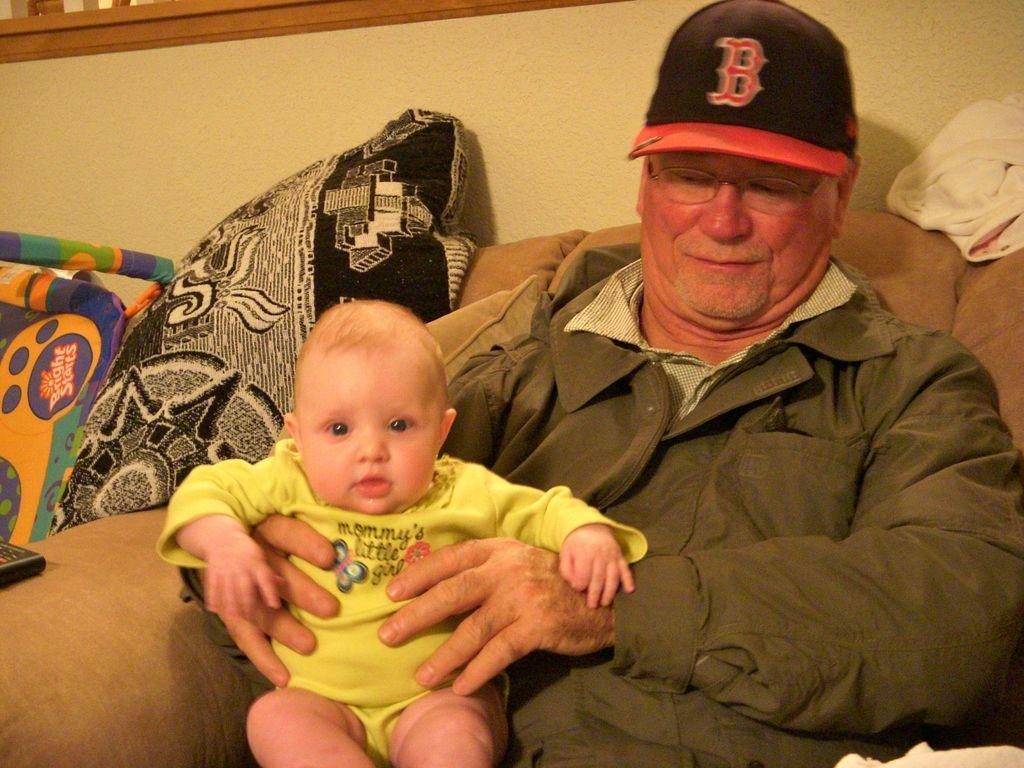Could you give a brief overview of what you see in this image? In this image on a sofa an old man is sitting wearing cap and jacket. He is holding a baby. In the background there is wall. There are cushions on sofa. 